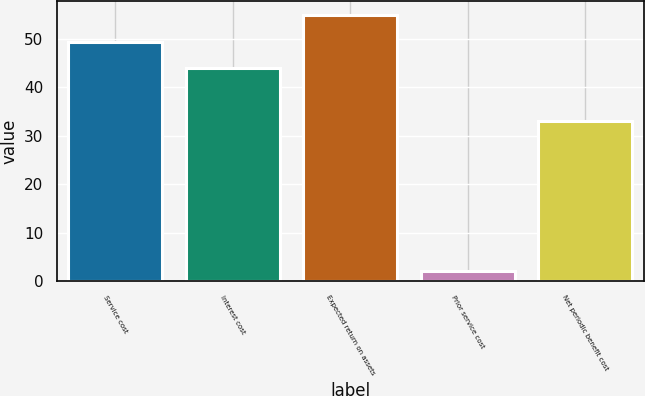Convert chart. <chart><loc_0><loc_0><loc_500><loc_500><bar_chart><fcel>Service cost<fcel>Interest cost<fcel>Expected return on assets<fcel>Prior service cost<fcel>Net periodic benefit cost<nl><fcel>49.3<fcel>44<fcel>55<fcel>2<fcel>33<nl></chart> 